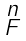Convert formula to latex. <formula><loc_0><loc_0><loc_500><loc_500>\begin{smallmatrix} n \\ F \\ \end{smallmatrix}</formula> 